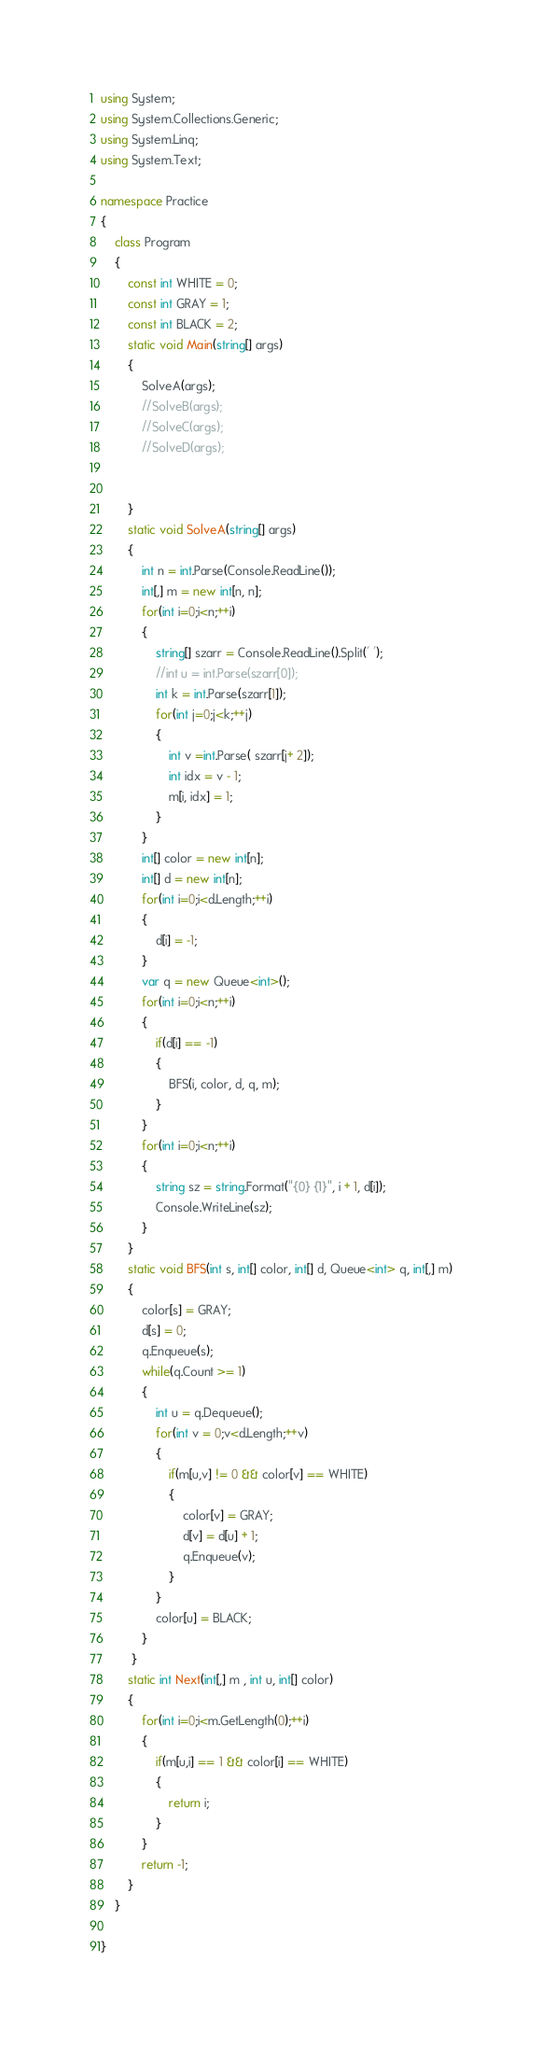Convert code to text. <code><loc_0><loc_0><loc_500><loc_500><_C#_>using System;
using System.Collections.Generic;
using System.Linq;
using System.Text;

namespace Practice
{
    class Program
    {
        const int WHITE = 0;
        const int GRAY = 1;
        const int BLACK = 2;
        static void Main(string[] args)
        {
            SolveA(args);
            //SolveB(args);
            //SolveC(args);
            //SolveD(args);


        }
        static void SolveA(string[] args)
        {
            int n = int.Parse(Console.ReadLine());
            int[,] m = new int[n, n];
            for(int i=0;i<n;++i)
            {
                string[] szarr = Console.ReadLine().Split(' ');
                //int u = int.Parse(szarr[0]);
                int k = int.Parse(szarr[1]);
                for(int j=0;j<k;++j)
                {
                    int v =int.Parse( szarr[j+ 2]);
                    int idx = v - 1;
                    m[i, idx] = 1;
                }
            }
            int[] color = new int[n];
            int[] d = new int[n];
            for(int i=0;i<d.Length;++i)
            {
                d[i] = -1;
            }
            var q = new Queue<int>();
            for(int i=0;i<n;++i)
            {
                if(d[i] == -1)
                {
                    BFS(i, color, d, q, m);
                }
            }
            for(int i=0;i<n;++i)
            {
                string sz = string.Format("{0} {1}", i + 1, d[i]);
                Console.WriteLine(sz);
            }
        }
        static void BFS(int s, int[] color, int[] d, Queue<int> q, int[,] m)
        {
            color[s] = GRAY;
            d[s] = 0;
            q.Enqueue(s);
            while(q.Count >= 1)
            {
                int u = q.Dequeue();
                for(int v = 0;v<d.Length;++v)
                {
                    if(m[u,v] != 0 && color[v] == WHITE)
                    {
                        color[v] = GRAY;
                        d[v] = d[u] + 1;
                        q.Enqueue(v);
                    }
                }
                color[u] = BLACK;
            }
         }
        static int Next(int[,] m , int u, int[] color)
        {
            for(int i=0;i<m.GetLength(0);++i)
            {
                if(m[u,i] == 1 && color[i] == WHITE)
                {
                    return i;
                }
            }
            return -1;
        }
    }

}

</code> 